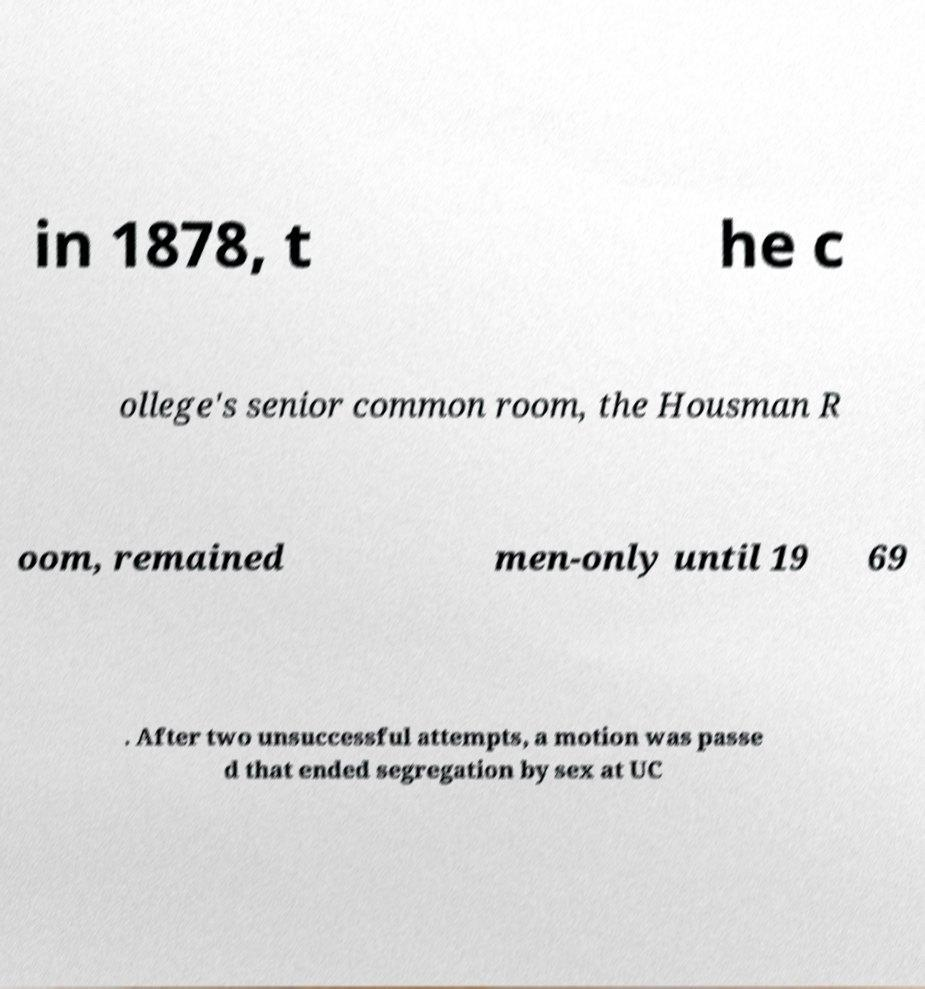Please read and relay the text visible in this image. What does it say? in 1878, t he c ollege's senior common room, the Housman R oom, remained men-only until 19 69 . After two unsuccessful attempts, a motion was passe d that ended segregation by sex at UC 